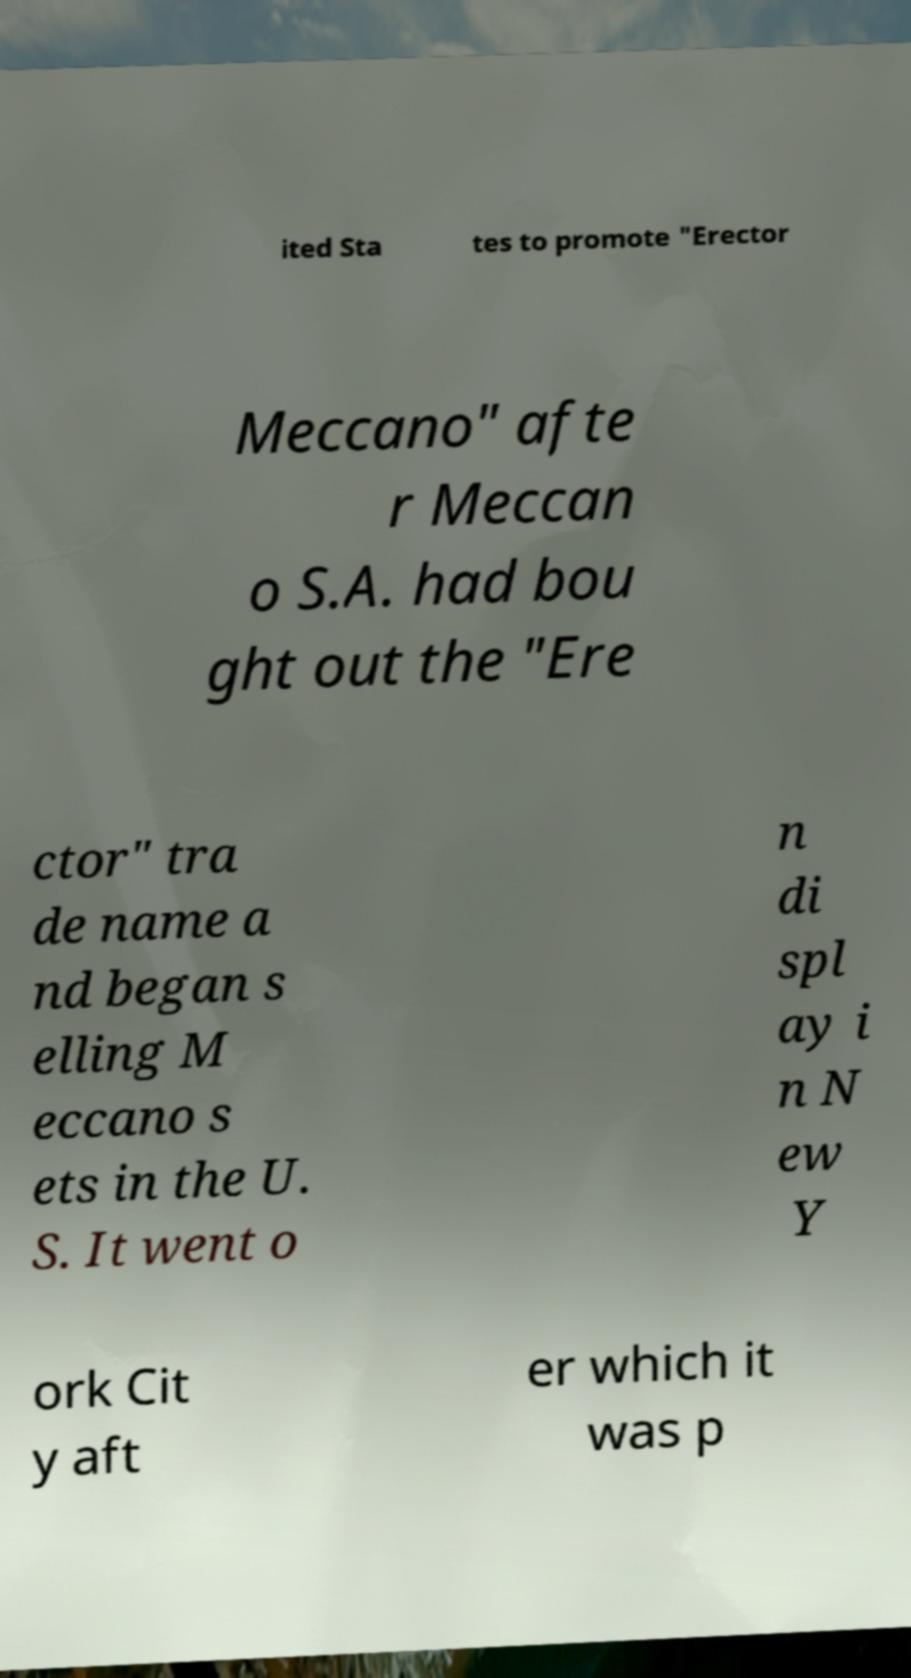Could you extract and type out the text from this image? ited Sta tes to promote "Erector Meccano" afte r Meccan o S.A. had bou ght out the "Ere ctor" tra de name a nd began s elling M eccano s ets in the U. S. It went o n di spl ay i n N ew Y ork Cit y aft er which it was p 